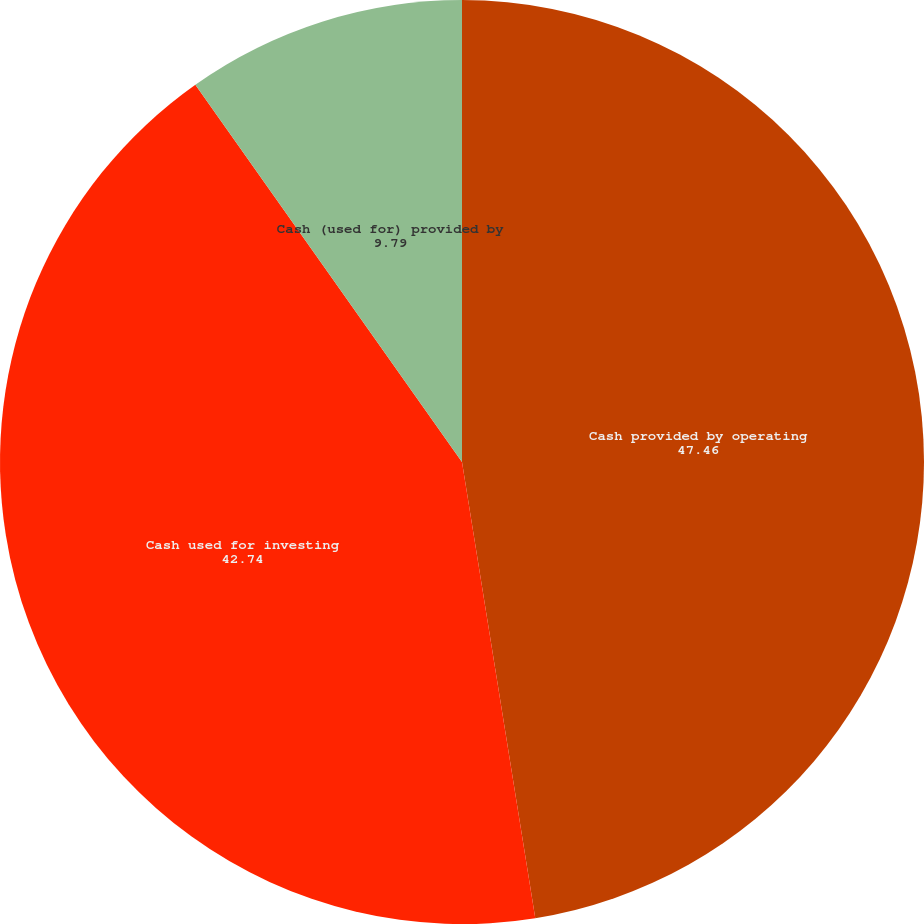Convert chart to OTSL. <chart><loc_0><loc_0><loc_500><loc_500><pie_chart><fcel>Cash provided by operating<fcel>Cash used for investing<fcel>Cash (used for) provided by<nl><fcel>47.46%<fcel>42.74%<fcel>9.79%<nl></chart> 